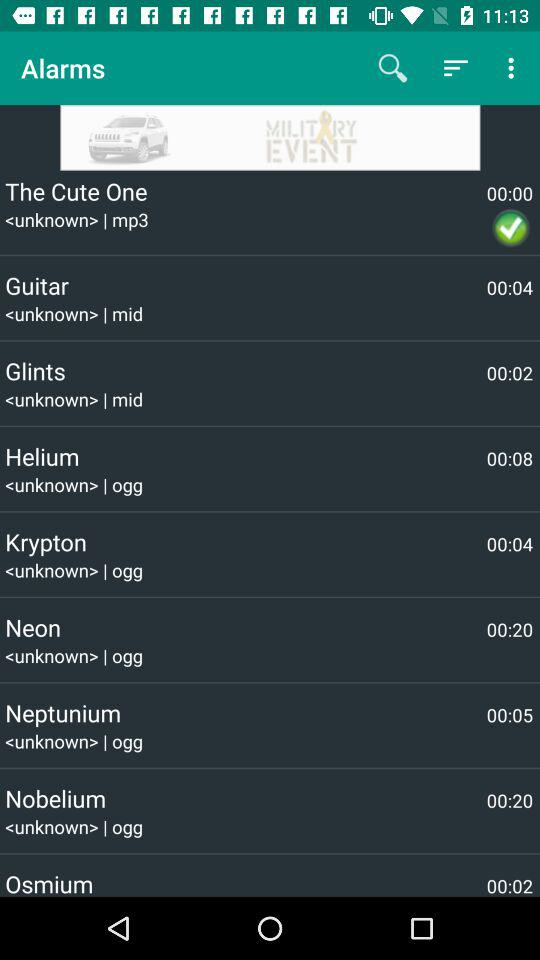00.02 is the duration of which ringtone?
When the provided information is insufficient, respond with <no answer>. <no answer> 